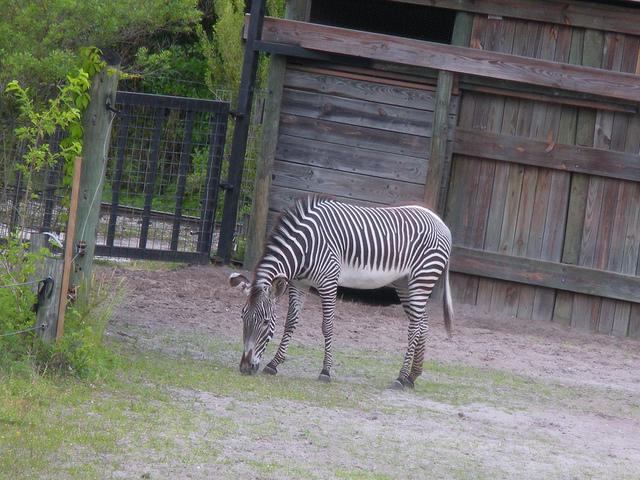What is cast?
Concise answer only. Nothing. How can you tell this location is not in the wild?
Answer briefly. Fence. What are the large pillars made out of?
Keep it brief. Wood. Where does the zebra probably sleep?
Concise answer only. Barn. What kind of fence is this?
Short answer required. Wire. How many different animals?
Short answer required. 1. Is there a fence?
Be succinct. Yes. How many creatures are in the photo?
Concise answer only. 1. What is the zebra eating?
Concise answer only. Grass. 